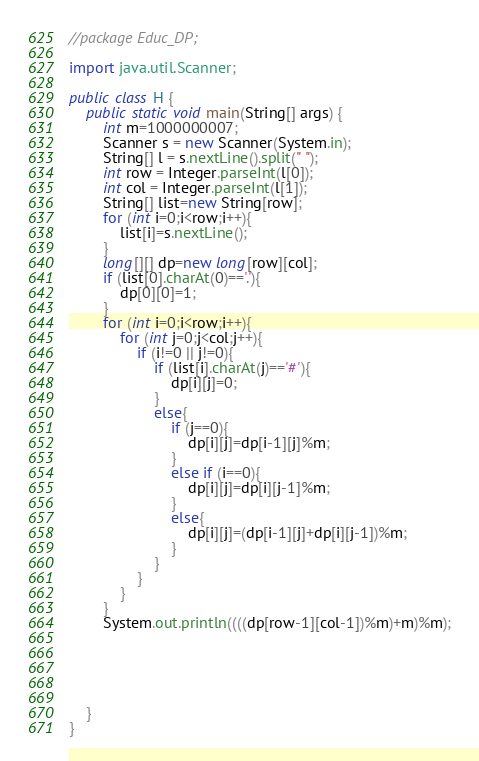Convert code to text. <code><loc_0><loc_0><loc_500><loc_500><_Java_>//package Educ_DP;

import java.util.Scanner;

public class H {
    public static void main(String[] args) {
        int m=1000000007;
        Scanner s = new Scanner(System.in);
        String[] l = s.nextLine().split(" ");
        int row = Integer.parseInt(l[0]);
        int col = Integer.parseInt(l[1]);
        String[] list=new String[row];
        for (int i=0;i<row;i++){
            list[i]=s.nextLine();
        }
        long[][] dp=new long[row][col];
        if (list[0].charAt(0)=='.'){
            dp[0][0]=1;
        }
        for (int i=0;i<row;i++){
            for (int j=0;j<col;j++){
                if (i!=0 || j!=0){
                    if (list[i].charAt(j)=='#'){
                        dp[i][j]=0;
                    }
                    else{
                        if (j==0){
                            dp[i][j]=dp[i-1][j]%m;
                        }
                        else if (i==0){
                            dp[i][j]=dp[i][j-1]%m;
                        }
                        else{
                            dp[i][j]=(dp[i-1][j]+dp[i][j-1])%m;
                        }
                    }
                }
            }
        }
        System.out.println((((dp[row-1][col-1])%m)+m)%m);





    }
}
</code> 